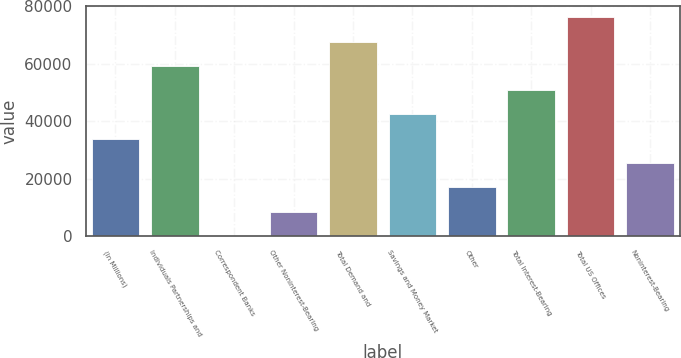<chart> <loc_0><loc_0><loc_500><loc_500><bar_chart><fcel>(In Millions)<fcel>Individuals Partnerships and<fcel>Correspondent Banks<fcel>Other Noninterest-Bearing<fcel>Total Demand and<fcel>Savings and Money Market<fcel>Other<fcel>Total Interest-Bearing<fcel>Total US Offices<fcel>Noninterest-Bearing<nl><fcel>33910<fcel>59283.3<fcel>78.9<fcel>8536.67<fcel>67741.1<fcel>42367.8<fcel>16994.4<fcel>50825.5<fcel>76198.8<fcel>25452.2<nl></chart> 